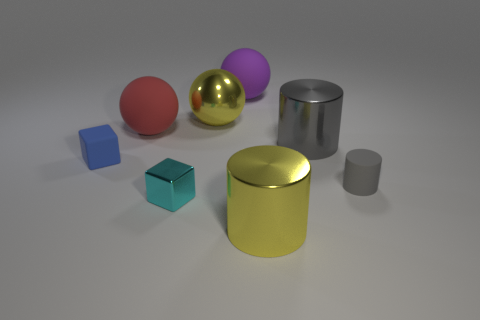The matte thing that is in front of the large red sphere and right of the big yellow metal sphere is what color?
Offer a terse response. Gray. Are there any other cyan metal objects that have the same shape as the tiny cyan metallic thing?
Keep it short and to the point. No. What is the large red ball made of?
Your answer should be compact. Rubber. There is a large yellow metallic cylinder; are there any purple matte spheres on the right side of it?
Offer a very short reply. No. Is the shape of the cyan thing the same as the blue object?
Offer a terse response. Yes. What number of other objects are the same size as the yellow cylinder?
Your answer should be very brief. 4. What number of things are either tiny blocks to the right of the tiny rubber block or large gray cubes?
Keep it short and to the point. 1. The small matte block is what color?
Offer a terse response. Blue. There is a gray cylinder that is in front of the small blue matte thing; what is its material?
Provide a short and direct response. Rubber. Does the tiny cyan thing have the same shape as the large yellow object in front of the tiny rubber cylinder?
Provide a short and direct response. No. 